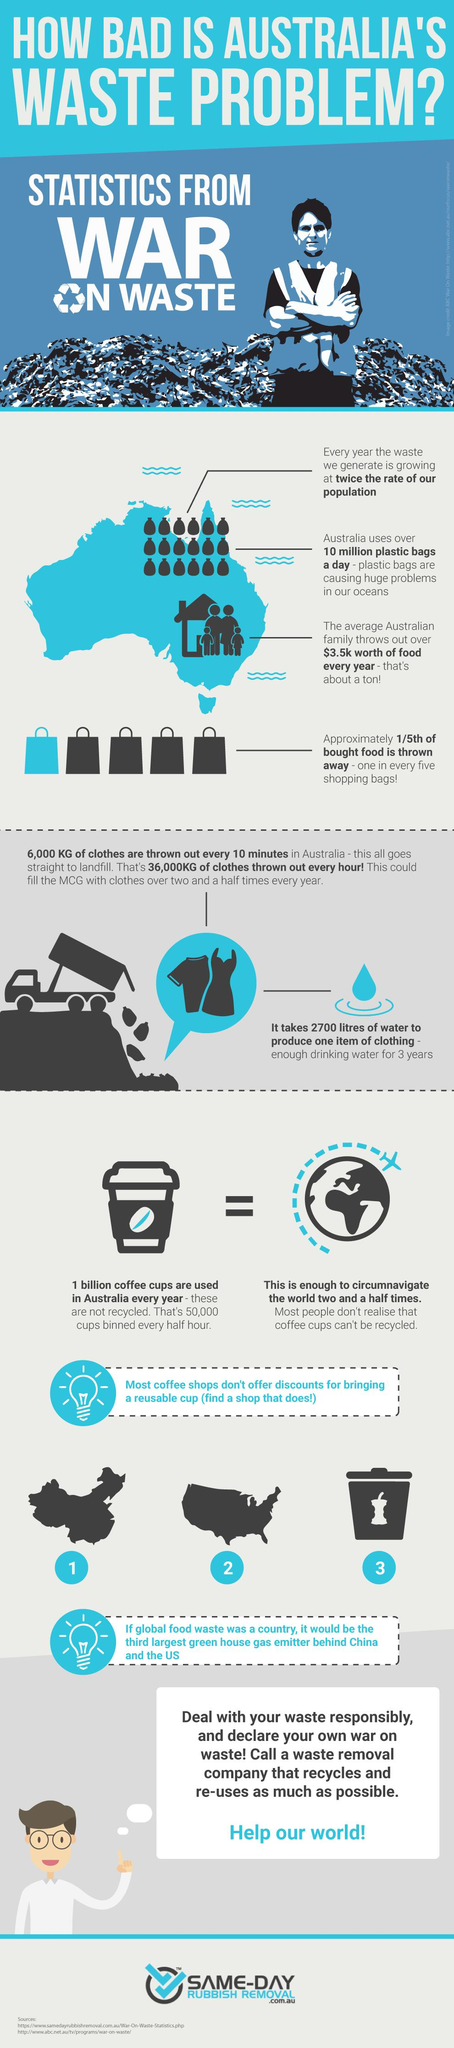Identify some key points in this picture. There is one shopping bag that is blue in color. The number of sources listed at the bottom is two. The infographic displays 25 garbage bags. There are 5 shopping bags displayed in the infographic. 